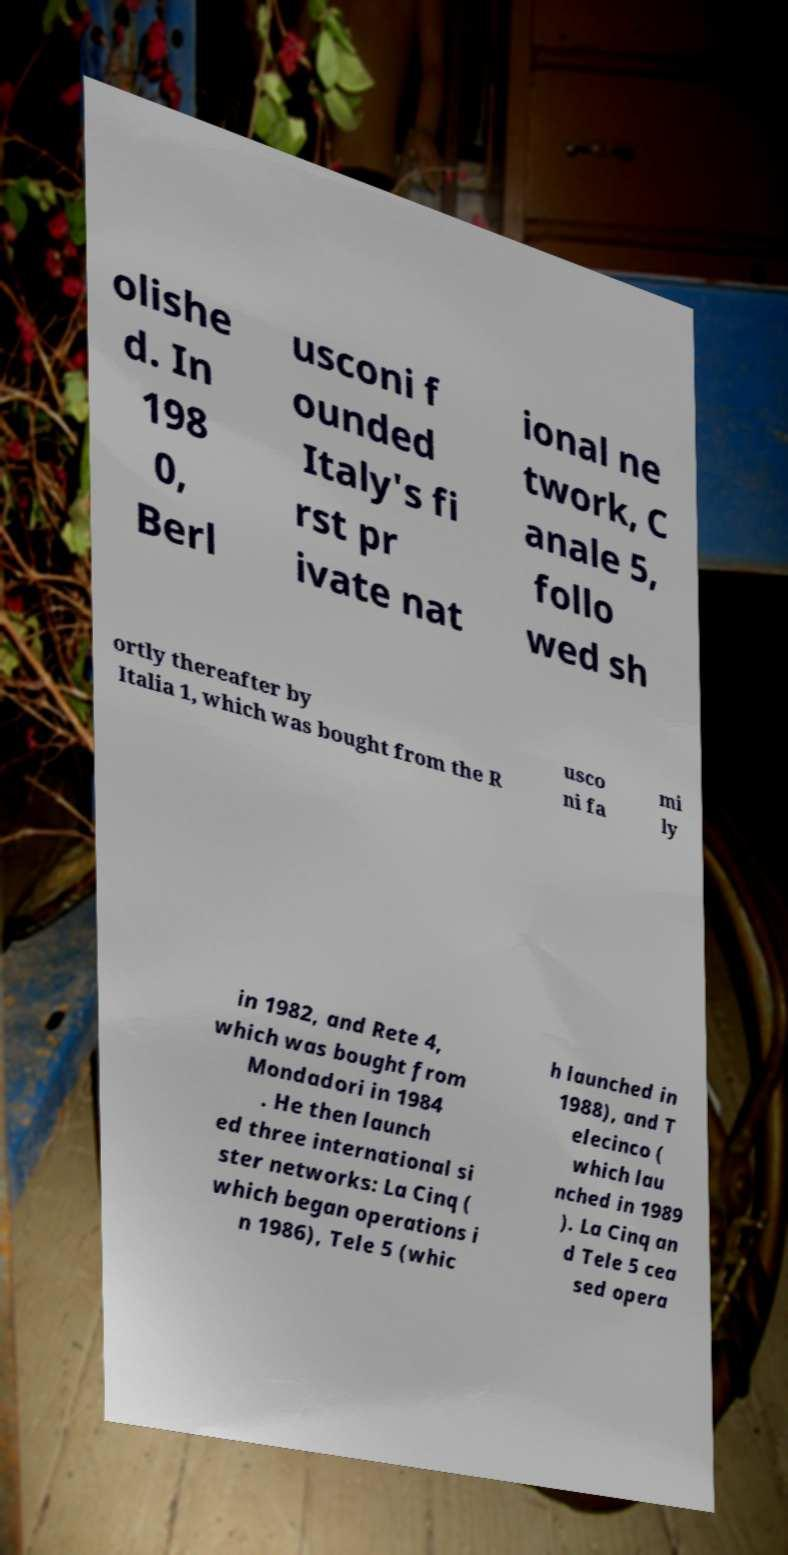Can you accurately transcribe the text from the provided image for me? olishe d. In 198 0, Berl usconi f ounded Italy's fi rst pr ivate nat ional ne twork, C anale 5, follo wed sh ortly thereafter by Italia 1, which was bought from the R usco ni fa mi ly in 1982, and Rete 4, which was bought from Mondadori in 1984 . He then launch ed three international si ster networks: La Cinq ( which began operations i n 1986), Tele 5 (whic h launched in 1988), and T elecinco ( which lau nched in 1989 ). La Cinq an d Tele 5 cea sed opera 